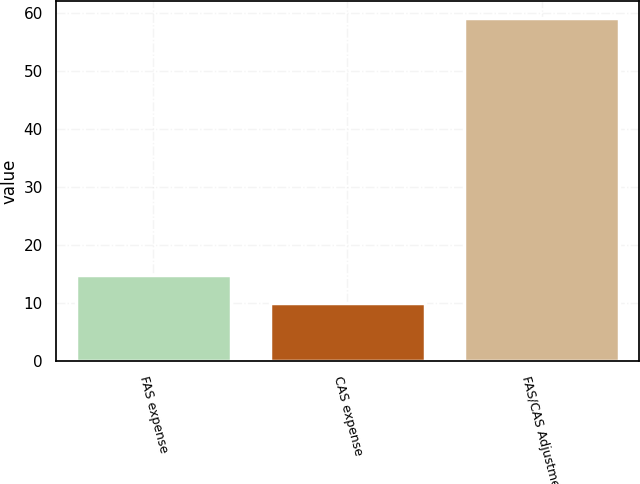Convert chart. <chart><loc_0><loc_0><loc_500><loc_500><bar_chart><fcel>FAS expense<fcel>CAS expense<fcel>FAS/CAS Adjustment<nl><fcel>14.9<fcel>10<fcel>59<nl></chart> 